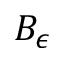<formula> <loc_0><loc_0><loc_500><loc_500>B _ { \epsilon }</formula> 